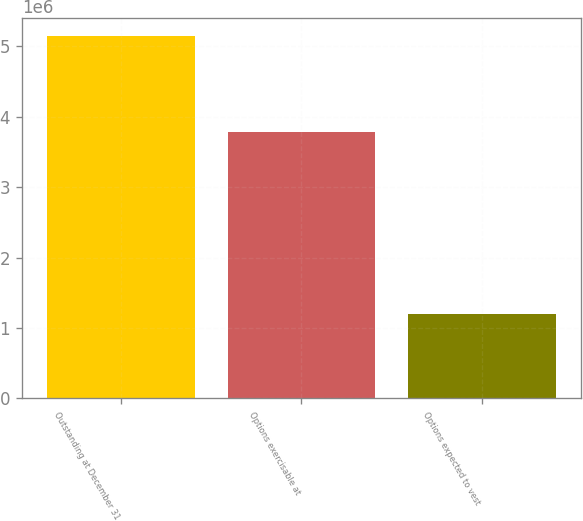Convert chart. <chart><loc_0><loc_0><loc_500><loc_500><bar_chart><fcel>Outstanding at December 31<fcel>Options exercisable at<fcel>Options expected to vest<nl><fcel>5.14574e+06<fcel>3.77935e+06<fcel>1.19382e+06<nl></chart> 